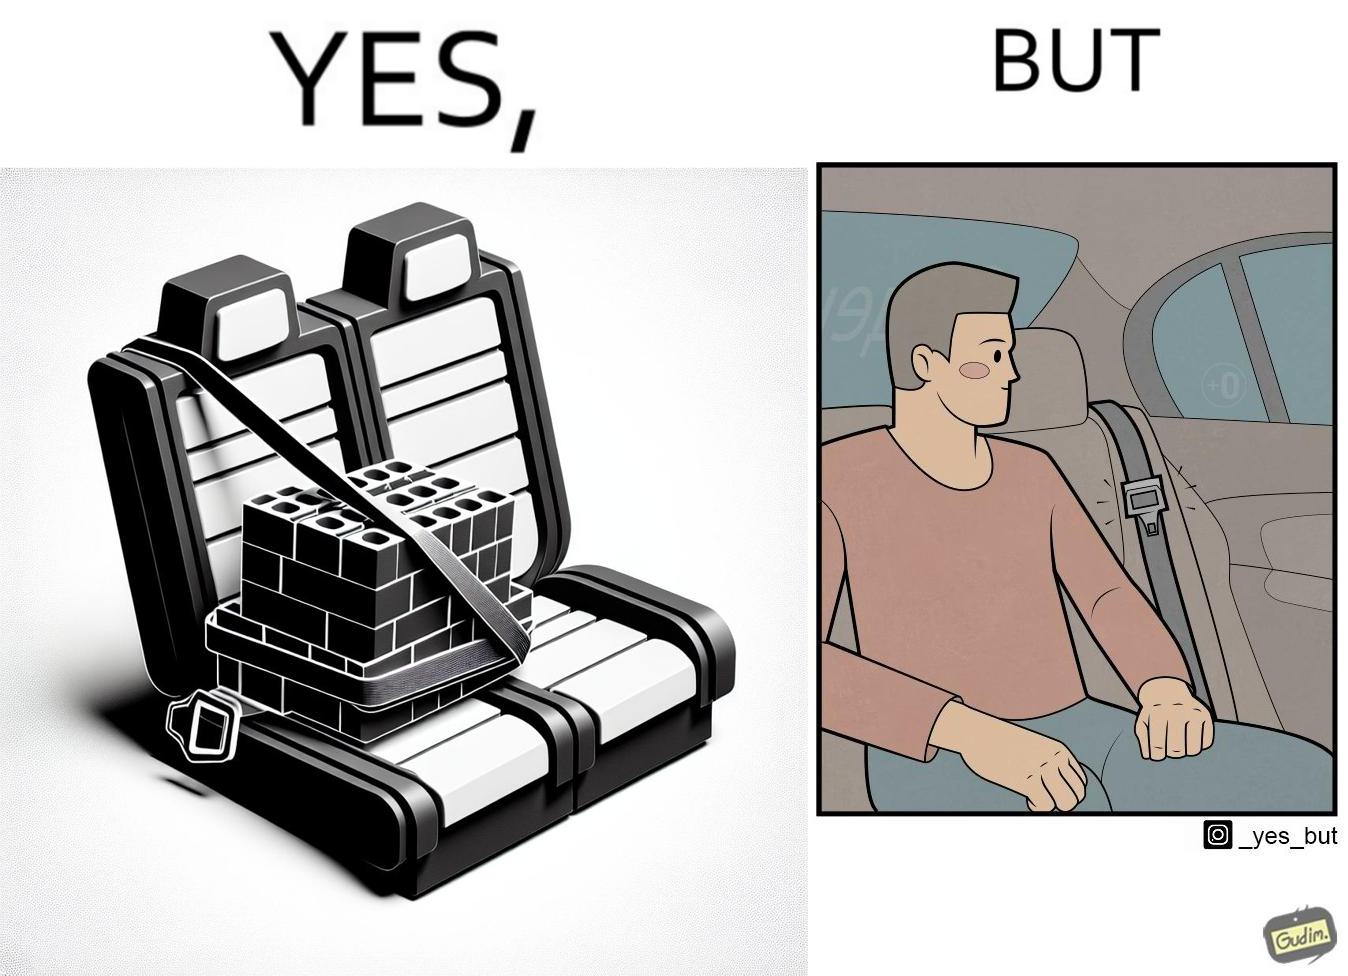Compare the left and right sides of this image. In the left part of the image: A box of building blocks, secured by the seatbelt in the backseat of a car. In the right part of the image: A person sitting in the backseat of a car, not wearing a seatbelt 